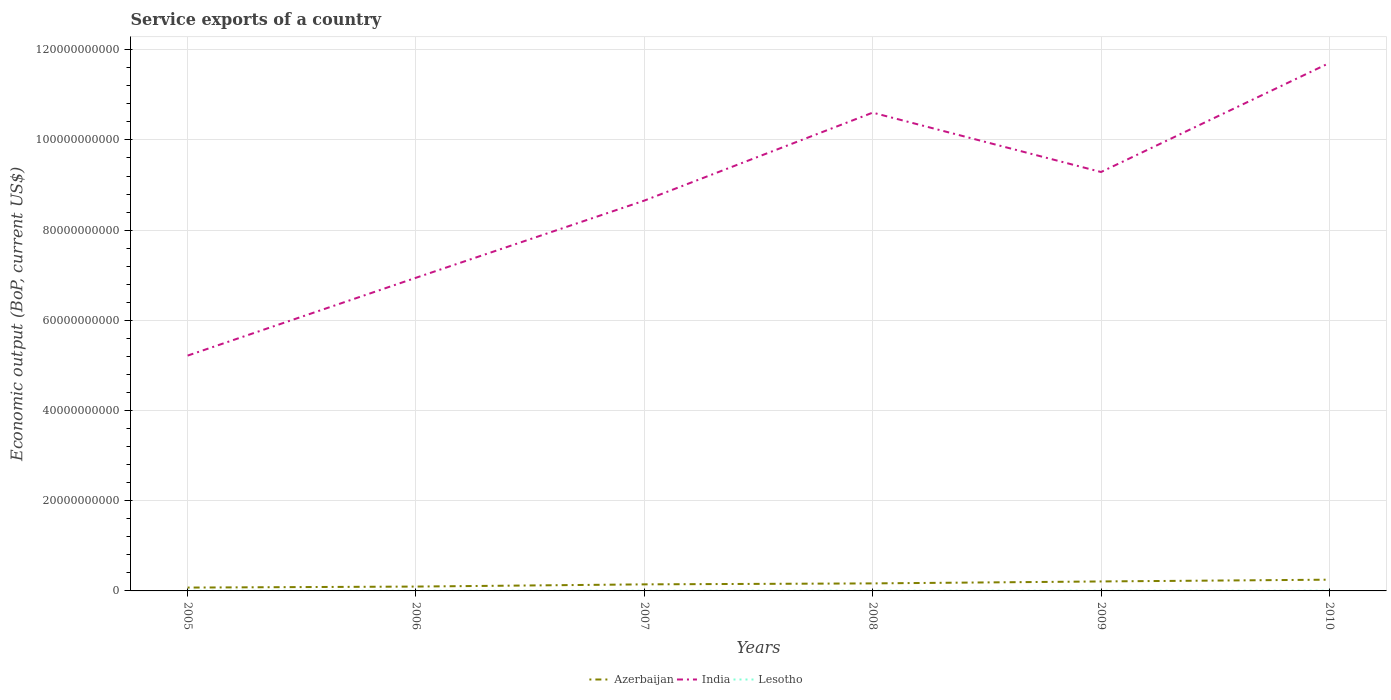Is the number of lines equal to the number of legend labels?
Offer a very short reply. Yes. Across all years, what is the maximum service exports in Lesotho?
Your answer should be very brief. 3.38e+07. In which year was the service exports in India maximum?
Make the answer very short. 2005. What is the total service exports in Azerbaijan in the graph?
Your response must be concise. -1.53e+09. What is the difference between the highest and the second highest service exports in Azerbaijan?
Offer a very short reply. 1.75e+09. Is the service exports in India strictly greater than the service exports in Azerbaijan over the years?
Offer a terse response. No. How many lines are there?
Your response must be concise. 3. Are the values on the major ticks of Y-axis written in scientific E-notation?
Keep it short and to the point. No. Does the graph contain any zero values?
Give a very brief answer. No. How many legend labels are there?
Offer a very short reply. 3. What is the title of the graph?
Offer a terse response. Service exports of a country. What is the label or title of the Y-axis?
Make the answer very short. Economic output (BoP, current US$). What is the Economic output (BoP, current US$) in Azerbaijan in 2005?
Provide a succinct answer. 7.41e+08. What is the Economic output (BoP, current US$) in India in 2005?
Give a very brief answer. 5.22e+1. What is the Economic output (BoP, current US$) in Lesotho in 2005?
Your response must be concise. 3.38e+07. What is the Economic output (BoP, current US$) in Azerbaijan in 2006?
Provide a succinct answer. 9.65e+08. What is the Economic output (BoP, current US$) in India in 2006?
Provide a succinct answer. 6.94e+1. What is the Economic output (BoP, current US$) in Lesotho in 2006?
Make the answer very short. 3.88e+07. What is the Economic output (BoP, current US$) in Azerbaijan in 2007?
Offer a terse response. 1.46e+09. What is the Economic output (BoP, current US$) in India in 2007?
Give a very brief answer. 8.66e+1. What is the Economic output (BoP, current US$) in Lesotho in 2007?
Give a very brief answer. 4.26e+07. What is the Economic output (BoP, current US$) in Azerbaijan in 2008?
Keep it short and to the point. 1.67e+09. What is the Economic output (BoP, current US$) of India in 2008?
Give a very brief answer. 1.06e+11. What is the Economic output (BoP, current US$) in Lesotho in 2008?
Make the answer very short. 4.83e+07. What is the Economic output (BoP, current US$) of Azerbaijan in 2009?
Provide a succinct answer. 2.10e+09. What is the Economic output (BoP, current US$) in India in 2009?
Your answer should be very brief. 9.29e+1. What is the Economic output (BoP, current US$) of Lesotho in 2009?
Give a very brief answer. 4.15e+07. What is the Economic output (BoP, current US$) of Azerbaijan in 2010?
Give a very brief answer. 2.49e+09. What is the Economic output (BoP, current US$) of India in 2010?
Make the answer very short. 1.17e+11. What is the Economic output (BoP, current US$) in Lesotho in 2010?
Offer a terse response. 4.77e+07. Across all years, what is the maximum Economic output (BoP, current US$) in Azerbaijan?
Offer a very short reply. 2.49e+09. Across all years, what is the maximum Economic output (BoP, current US$) of India?
Make the answer very short. 1.17e+11. Across all years, what is the maximum Economic output (BoP, current US$) of Lesotho?
Make the answer very short. 4.83e+07. Across all years, what is the minimum Economic output (BoP, current US$) in Azerbaijan?
Your answer should be compact. 7.41e+08. Across all years, what is the minimum Economic output (BoP, current US$) in India?
Your answer should be compact. 5.22e+1. Across all years, what is the minimum Economic output (BoP, current US$) in Lesotho?
Give a very brief answer. 3.38e+07. What is the total Economic output (BoP, current US$) of Azerbaijan in the graph?
Ensure brevity in your answer.  9.43e+09. What is the total Economic output (BoP, current US$) of India in the graph?
Ensure brevity in your answer.  5.24e+11. What is the total Economic output (BoP, current US$) of Lesotho in the graph?
Provide a succinct answer. 2.53e+08. What is the difference between the Economic output (BoP, current US$) in Azerbaijan in 2005 and that in 2006?
Ensure brevity in your answer.  -2.24e+08. What is the difference between the Economic output (BoP, current US$) in India in 2005 and that in 2006?
Provide a succinct answer. -1.73e+1. What is the difference between the Economic output (BoP, current US$) of Lesotho in 2005 and that in 2006?
Offer a very short reply. -5.01e+06. What is the difference between the Economic output (BoP, current US$) in Azerbaijan in 2005 and that in 2007?
Ensure brevity in your answer.  -7.14e+08. What is the difference between the Economic output (BoP, current US$) in India in 2005 and that in 2007?
Ensure brevity in your answer.  -3.44e+1. What is the difference between the Economic output (BoP, current US$) in Lesotho in 2005 and that in 2007?
Offer a very short reply. -8.77e+06. What is the difference between the Economic output (BoP, current US$) of Azerbaijan in 2005 and that in 2008?
Give a very brief answer. -9.27e+08. What is the difference between the Economic output (BoP, current US$) in India in 2005 and that in 2008?
Offer a very short reply. -5.39e+1. What is the difference between the Economic output (BoP, current US$) of Lesotho in 2005 and that in 2008?
Your answer should be compact. -1.46e+07. What is the difference between the Economic output (BoP, current US$) in Azerbaijan in 2005 and that in 2009?
Make the answer very short. -1.36e+09. What is the difference between the Economic output (BoP, current US$) in India in 2005 and that in 2009?
Give a very brief answer. -4.07e+1. What is the difference between the Economic output (BoP, current US$) of Lesotho in 2005 and that in 2009?
Your response must be concise. -7.75e+06. What is the difference between the Economic output (BoP, current US$) of Azerbaijan in 2005 and that in 2010?
Your response must be concise. -1.75e+09. What is the difference between the Economic output (BoP, current US$) of India in 2005 and that in 2010?
Ensure brevity in your answer.  -6.49e+1. What is the difference between the Economic output (BoP, current US$) of Lesotho in 2005 and that in 2010?
Provide a succinct answer. -1.39e+07. What is the difference between the Economic output (BoP, current US$) in Azerbaijan in 2006 and that in 2007?
Your answer should be very brief. -4.90e+08. What is the difference between the Economic output (BoP, current US$) of India in 2006 and that in 2007?
Give a very brief answer. -1.71e+1. What is the difference between the Economic output (BoP, current US$) in Lesotho in 2006 and that in 2007?
Ensure brevity in your answer.  -3.76e+06. What is the difference between the Economic output (BoP, current US$) of Azerbaijan in 2006 and that in 2008?
Give a very brief answer. -7.03e+08. What is the difference between the Economic output (BoP, current US$) of India in 2006 and that in 2008?
Your response must be concise. -3.66e+1. What is the difference between the Economic output (BoP, current US$) of Lesotho in 2006 and that in 2008?
Ensure brevity in your answer.  -9.54e+06. What is the difference between the Economic output (BoP, current US$) in Azerbaijan in 2006 and that in 2009?
Provide a succinct answer. -1.14e+09. What is the difference between the Economic output (BoP, current US$) of India in 2006 and that in 2009?
Give a very brief answer. -2.34e+1. What is the difference between the Economic output (BoP, current US$) in Lesotho in 2006 and that in 2009?
Keep it short and to the point. -2.74e+06. What is the difference between the Economic output (BoP, current US$) of Azerbaijan in 2006 and that in 2010?
Provide a succinct answer. -1.53e+09. What is the difference between the Economic output (BoP, current US$) in India in 2006 and that in 2010?
Make the answer very short. -4.76e+1. What is the difference between the Economic output (BoP, current US$) of Lesotho in 2006 and that in 2010?
Offer a terse response. -8.93e+06. What is the difference between the Economic output (BoP, current US$) of Azerbaijan in 2007 and that in 2008?
Your response must be concise. -2.13e+08. What is the difference between the Economic output (BoP, current US$) of India in 2007 and that in 2008?
Ensure brevity in your answer.  -1.95e+1. What is the difference between the Economic output (BoP, current US$) of Lesotho in 2007 and that in 2008?
Your answer should be very brief. -5.78e+06. What is the difference between the Economic output (BoP, current US$) in Azerbaijan in 2007 and that in 2009?
Make the answer very short. -6.45e+08. What is the difference between the Economic output (BoP, current US$) of India in 2007 and that in 2009?
Your answer should be very brief. -6.34e+09. What is the difference between the Economic output (BoP, current US$) of Lesotho in 2007 and that in 2009?
Ensure brevity in your answer.  1.02e+06. What is the difference between the Economic output (BoP, current US$) of Azerbaijan in 2007 and that in 2010?
Offer a very short reply. -1.04e+09. What is the difference between the Economic output (BoP, current US$) of India in 2007 and that in 2010?
Offer a terse response. -3.05e+1. What is the difference between the Economic output (BoP, current US$) of Lesotho in 2007 and that in 2010?
Provide a succinct answer. -5.17e+06. What is the difference between the Economic output (BoP, current US$) of Azerbaijan in 2008 and that in 2009?
Give a very brief answer. -4.32e+08. What is the difference between the Economic output (BoP, current US$) in India in 2008 and that in 2009?
Provide a succinct answer. 1.32e+1. What is the difference between the Economic output (BoP, current US$) of Lesotho in 2008 and that in 2009?
Your answer should be compact. 6.80e+06. What is the difference between the Economic output (BoP, current US$) of Azerbaijan in 2008 and that in 2010?
Keep it short and to the point. -8.25e+08. What is the difference between the Economic output (BoP, current US$) in India in 2008 and that in 2010?
Your answer should be very brief. -1.10e+1. What is the difference between the Economic output (BoP, current US$) in Lesotho in 2008 and that in 2010?
Provide a short and direct response. 6.12e+05. What is the difference between the Economic output (BoP, current US$) in Azerbaijan in 2009 and that in 2010?
Your response must be concise. -3.93e+08. What is the difference between the Economic output (BoP, current US$) of India in 2009 and that in 2010?
Your response must be concise. -2.42e+1. What is the difference between the Economic output (BoP, current US$) of Lesotho in 2009 and that in 2010?
Keep it short and to the point. -6.19e+06. What is the difference between the Economic output (BoP, current US$) of Azerbaijan in 2005 and the Economic output (BoP, current US$) of India in 2006?
Offer a terse response. -6.87e+1. What is the difference between the Economic output (BoP, current US$) in Azerbaijan in 2005 and the Economic output (BoP, current US$) in Lesotho in 2006?
Your response must be concise. 7.03e+08. What is the difference between the Economic output (BoP, current US$) of India in 2005 and the Economic output (BoP, current US$) of Lesotho in 2006?
Provide a short and direct response. 5.21e+1. What is the difference between the Economic output (BoP, current US$) in Azerbaijan in 2005 and the Economic output (BoP, current US$) in India in 2007?
Offer a very short reply. -8.58e+1. What is the difference between the Economic output (BoP, current US$) in Azerbaijan in 2005 and the Economic output (BoP, current US$) in Lesotho in 2007?
Make the answer very short. 6.99e+08. What is the difference between the Economic output (BoP, current US$) of India in 2005 and the Economic output (BoP, current US$) of Lesotho in 2007?
Make the answer very short. 5.21e+1. What is the difference between the Economic output (BoP, current US$) in Azerbaijan in 2005 and the Economic output (BoP, current US$) in India in 2008?
Your response must be concise. -1.05e+11. What is the difference between the Economic output (BoP, current US$) in Azerbaijan in 2005 and the Economic output (BoP, current US$) in Lesotho in 2008?
Provide a succinct answer. 6.93e+08. What is the difference between the Economic output (BoP, current US$) of India in 2005 and the Economic output (BoP, current US$) of Lesotho in 2008?
Ensure brevity in your answer.  5.21e+1. What is the difference between the Economic output (BoP, current US$) of Azerbaijan in 2005 and the Economic output (BoP, current US$) of India in 2009?
Make the answer very short. -9.21e+1. What is the difference between the Economic output (BoP, current US$) in Azerbaijan in 2005 and the Economic output (BoP, current US$) in Lesotho in 2009?
Provide a succinct answer. 7.00e+08. What is the difference between the Economic output (BoP, current US$) of India in 2005 and the Economic output (BoP, current US$) of Lesotho in 2009?
Provide a short and direct response. 5.21e+1. What is the difference between the Economic output (BoP, current US$) of Azerbaijan in 2005 and the Economic output (BoP, current US$) of India in 2010?
Your response must be concise. -1.16e+11. What is the difference between the Economic output (BoP, current US$) in Azerbaijan in 2005 and the Economic output (BoP, current US$) in Lesotho in 2010?
Your answer should be very brief. 6.94e+08. What is the difference between the Economic output (BoP, current US$) in India in 2005 and the Economic output (BoP, current US$) in Lesotho in 2010?
Make the answer very short. 5.21e+1. What is the difference between the Economic output (BoP, current US$) in Azerbaijan in 2006 and the Economic output (BoP, current US$) in India in 2007?
Keep it short and to the point. -8.56e+1. What is the difference between the Economic output (BoP, current US$) in Azerbaijan in 2006 and the Economic output (BoP, current US$) in Lesotho in 2007?
Ensure brevity in your answer.  9.23e+08. What is the difference between the Economic output (BoP, current US$) of India in 2006 and the Economic output (BoP, current US$) of Lesotho in 2007?
Ensure brevity in your answer.  6.94e+1. What is the difference between the Economic output (BoP, current US$) in Azerbaijan in 2006 and the Economic output (BoP, current US$) in India in 2008?
Your answer should be compact. -1.05e+11. What is the difference between the Economic output (BoP, current US$) of Azerbaijan in 2006 and the Economic output (BoP, current US$) of Lesotho in 2008?
Keep it short and to the point. 9.17e+08. What is the difference between the Economic output (BoP, current US$) in India in 2006 and the Economic output (BoP, current US$) in Lesotho in 2008?
Provide a short and direct response. 6.94e+1. What is the difference between the Economic output (BoP, current US$) in Azerbaijan in 2006 and the Economic output (BoP, current US$) in India in 2009?
Keep it short and to the point. -9.19e+1. What is the difference between the Economic output (BoP, current US$) of Azerbaijan in 2006 and the Economic output (BoP, current US$) of Lesotho in 2009?
Provide a succinct answer. 9.24e+08. What is the difference between the Economic output (BoP, current US$) of India in 2006 and the Economic output (BoP, current US$) of Lesotho in 2009?
Ensure brevity in your answer.  6.94e+1. What is the difference between the Economic output (BoP, current US$) of Azerbaijan in 2006 and the Economic output (BoP, current US$) of India in 2010?
Provide a succinct answer. -1.16e+11. What is the difference between the Economic output (BoP, current US$) in Azerbaijan in 2006 and the Economic output (BoP, current US$) in Lesotho in 2010?
Your answer should be very brief. 9.18e+08. What is the difference between the Economic output (BoP, current US$) in India in 2006 and the Economic output (BoP, current US$) in Lesotho in 2010?
Offer a very short reply. 6.94e+1. What is the difference between the Economic output (BoP, current US$) of Azerbaijan in 2007 and the Economic output (BoP, current US$) of India in 2008?
Your answer should be very brief. -1.05e+11. What is the difference between the Economic output (BoP, current US$) of Azerbaijan in 2007 and the Economic output (BoP, current US$) of Lesotho in 2008?
Offer a terse response. 1.41e+09. What is the difference between the Economic output (BoP, current US$) in India in 2007 and the Economic output (BoP, current US$) in Lesotho in 2008?
Keep it short and to the point. 8.65e+1. What is the difference between the Economic output (BoP, current US$) in Azerbaijan in 2007 and the Economic output (BoP, current US$) in India in 2009?
Provide a short and direct response. -9.14e+1. What is the difference between the Economic output (BoP, current US$) in Azerbaijan in 2007 and the Economic output (BoP, current US$) in Lesotho in 2009?
Provide a succinct answer. 1.41e+09. What is the difference between the Economic output (BoP, current US$) of India in 2007 and the Economic output (BoP, current US$) of Lesotho in 2009?
Provide a succinct answer. 8.65e+1. What is the difference between the Economic output (BoP, current US$) in Azerbaijan in 2007 and the Economic output (BoP, current US$) in India in 2010?
Make the answer very short. -1.16e+11. What is the difference between the Economic output (BoP, current US$) of Azerbaijan in 2007 and the Economic output (BoP, current US$) of Lesotho in 2010?
Provide a short and direct response. 1.41e+09. What is the difference between the Economic output (BoP, current US$) in India in 2007 and the Economic output (BoP, current US$) in Lesotho in 2010?
Provide a short and direct response. 8.65e+1. What is the difference between the Economic output (BoP, current US$) in Azerbaijan in 2008 and the Economic output (BoP, current US$) in India in 2009?
Offer a terse response. -9.12e+1. What is the difference between the Economic output (BoP, current US$) in Azerbaijan in 2008 and the Economic output (BoP, current US$) in Lesotho in 2009?
Your answer should be compact. 1.63e+09. What is the difference between the Economic output (BoP, current US$) in India in 2008 and the Economic output (BoP, current US$) in Lesotho in 2009?
Ensure brevity in your answer.  1.06e+11. What is the difference between the Economic output (BoP, current US$) in Azerbaijan in 2008 and the Economic output (BoP, current US$) in India in 2010?
Ensure brevity in your answer.  -1.15e+11. What is the difference between the Economic output (BoP, current US$) in Azerbaijan in 2008 and the Economic output (BoP, current US$) in Lesotho in 2010?
Ensure brevity in your answer.  1.62e+09. What is the difference between the Economic output (BoP, current US$) in India in 2008 and the Economic output (BoP, current US$) in Lesotho in 2010?
Your response must be concise. 1.06e+11. What is the difference between the Economic output (BoP, current US$) of Azerbaijan in 2009 and the Economic output (BoP, current US$) of India in 2010?
Provide a short and direct response. -1.15e+11. What is the difference between the Economic output (BoP, current US$) in Azerbaijan in 2009 and the Economic output (BoP, current US$) in Lesotho in 2010?
Ensure brevity in your answer.  2.05e+09. What is the difference between the Economic output (BoP, current US$) in India in 2009 and the Economic output (BoP, current US$) in Lesotho in 2010?
Provide a short and direct response. 9.28e+1. What is the average Economic output (BoP, current US$) in Azerbaijan per year?
Keep it short and to the point. 1.57e+09. What is the average Economic output (BoP, current US$) in India per year?
Your answer should be very brief. 8.74e+1. What is the average Economic output (BoP, current US$) of Lesotho per year?
Provide a succinct answer. 4.21e+07. In the year 2005, what is the difference between the Economic output (BoP, current US$) in Azerbaijan and Economic output (BoP, current US$) in India?
Provide a succinct answer. -5.14e+1. In the year 2005, what is the difference between the Economic output (BoP, current US$) in Azerbaijan and Economic output (BoP, current US$) in Lesotho?
Keep it short and to the point. 7.08e+08. In the year 2005, what is the difference between the Economic output (BoP, current US$) in India and Economic output (BoP, current US$) in Lesotho?
Make the answer very short. 5.21e+1. In the year 2006, what is the difference between the Economic output (BoP, current US$) in Azerbaijan and Economic output (BoP, current US$) in India?
Ensure brevity in your answer.  -6.85e+1. In the year 2006, what is the difference between the Economic output (BoP, current US$) in Azerbaijan and Economic output (BoP, current US$) in Lesotho?
Ensure brevity in your answer.  9.27e+08. In the year 2006, what is the difference between the Economic output (BoP, current US$) of India and Economic output (BoP, current US$) of Lesotho?
Your answer should be compact. 6.94e+1. In the year 2007, what is the difference between the Economic output (BoP, current US$) of Azerbaijan and Economic output (BoP, current US$) of India?
Give a very brief answer. -8.51e+1. In the year 2007, what is the difference between the Economic output (BoP, current US$) of Azerbaijan and Economic output (BoP, current US$) of Lesotho?
Give a very brief answer. 1.41e+09. In the year 2007, what is the difference between the Economic output (BoP, current US$) in India and Economic output (BoP, current US$) in Lesotho?
Your answer should be compact. 8.65e+1. In the year 2008, what is the difference between the Economic output (BoP, current US$) of Azerbaijan and Economic output (BoP, current US$) of India?
Offer a very short reply. -1.04e+11. In the year 2008, what is the difference between the Economic output (BoP, current US$) in Azerbaijan and Economic output (BoP, current US$) in Lesotho?
Your answer should be very brief. 1.62e+09. In the year 2008, what is the difference between the Economic output (BoP, current US$) of India and Economic output (BoP, current US$) of Lesotho?
Keep it short and to the point. 1.06e+11. In the year 2009, what is the difference between the Economic output (BoP, current US$) of Azerbaijan and Economic output (BoP, current US$) of India?
Provide a short and direct response. -9.08e+1. In the year 2009, what is the difference between the Economic output (BoP, current US$) of Azerbaijan and Economic output (BoP, current US$) of Lesotho?
Offer a very short reply. 2.06e+09. In the year 2009, what is the difference between the Economic output (BoP, current US$) in India and Economic output (BoP, current US$) in Lesotho?
Your response must be concise. 9.28e+1. In the year 2010, what is the difference between the Economic output (BoP, current US$) of Azerbaijan and Economic output (BoP, current US$) of India?
Keep it short and to the point. -1.15e+11. In the year 2010, what is the difference between the Economic output (BoP, current US$) of Azerbaijan and Economic output (BoP, current US$) of Lesotho?
Your response must be concise. 2.45e+09. In the year 2010, what is the difference between the Economic output (BoP, current US$) in India and Economic output (BoP, current US$) in Lesotho?
Your response must be concise. 1.17e+11. What is the ratio of the Economic output (BoP, current US$) in Azerbaijan in 2005 to that in 2006?
Provide a succinct answer. 0.77. What is the ratio of the Economic output (BoP, current US$) of India in 2005 to that in 2006?
Provide a succinct answer. 0.75. What is the ratio of the Economic output (BoP, current US$) in Lesotho in 2005 to that in 2006?
Ensure brevity in your answer.  0.87. What is the ratio of the Economic output (BoP, current US$) of Azerbaijan in 2005 to that in 2007?
Give a very brief answer. 0.51. What is the ratio of the Economic output (BoP, current US$) in India in 2005 to that in 2007?
Your answer should be very brief. 0.6. What is the ratio of the Economic output (BoP, current US$) in Lesotho in 2005 to that in 2007?
Provide a short and direct response. 0.79. What is the ratio of the Economic output (BoP, current US$) of Azerbaijan in 2005 to that in 2008?
Give a very brief answer. 0.44. What is the ratio of the Economic output (BoP, current US$) in India in 2005 to that in 2008?
Offer a very short reply. 0.49. What is the ratio of the Economic output (BoP, current US$) of Lesotho in 2005 to that in 2008?
Give a very brief answer. 0.7. What is the ratio of the Economic output (BoP, current US$) in Azerbaijan in 2005 to that in 2009?
Offer a very short reply. 0.35. What is the ratio of the Economic output (BoP, current US$) of India in 2005 to that in 2009?
Offer a very short reply. 0.56. What is the ratio of the Economic output (BoP, current US$) in Lesotho in 2005 to that in 2009?
Offer a very short reply. 0.81. What is the ratio of the Economic output (BoP, current US$) in Azerbaijan in 2005 to that in 2010?
Provide a short and direct response. 0.3. What is the ratio of the Economic output (BoP, current US$) in India in 2005 to that in 2010?
Keep it short and to the point. 0.45. What is the ratio of the Economic output (BoP, current US$) of Lesotho in 2005 to that in 2010?
Provide a succinct answer. 0.71. What is the ratio of the Economic output (BoP, current US$) in Azerbaijan in 2006 to that in 2007?
Provide a succinct answer. 0.66. What is the ratio of the Economic output (BoP, current US$) of India in 2006 to that in 2007?
Make the answer very short. 0.8. What is the ratio of the Economic output (BoP, current US$) of Lesotho in 2006 to that in 2007?
Give a very brief answer. 0.91. What is the ratio of the Economic output (BoP, current US$) of Azerbaijan in 2006 to that in 2008?
Your response must be concise. 0.58. What is the ratio of the Economic output (BoP, current US$) of India in 2006 to that in 2008?
Provide a short and direct response. 0.65. What is the ratio of the Economic output (BoP, current US$) in Lesotho in 2006 to that in 2008?
Provide a short and direct response. 0.8. What is the ratio of the Economic output (BoP, current US$) of Azerbaijan in 2006 to that in 2009?
Your response must be concise. 0.46. What is the ratio of the Economic output (BoP, current US$) of India in 2006 to that in 2009?
Provide a short and direct response. 0.75. What is the ratio of the Economic output (BoP, current US$) in Lesotho in 2006 to that in 2009?
Give a very brief answer. 0.93. What is the ratio of the Economic output (BoP, current US$) in Azerbaijan in 2006 to that in 2010?
Make the answer very short. 0.39. What is the ratio of the Economic output (BoP, current US$) in India in 2006 to that in 2010?
Keep it short and to the point. 0.59. What is the ratio of the Economic output (BoP, current US$) of Lesotho in 2006 to that in 2010?
Ensure brevity in your answer.  0.81. What is the ratio of the Economic output (BoP, current US$) of Azerbaijan in 2007 to that in 2008?
Make the answer very short. 0.87. What is the ratio of the Economic output (BoP, current US$) of India in 2007 to that in 2008?
Provide a short and direct response. 0.82. What is the ratio of the Economic output (BoP, current US$) in Lesotho in 2007 to that in 2008?
Your answer should be compact. 0.88. What is the ratio of the Economic output (BoP, current US$) in Azerbaijan in 2007 to that in 2009?
Keep it short and to the point. 0.69. What is the ratio of the Economic output (BoP, current US$) of India in 2007 to that in 2009?
Your response must be concise. 0.93. What is the ratio of the Economic output (BoP, current US$) of Lesotho in 2007 to that in 2009?
Offer a very short reply. 1.02. What is the ratio of the Economic output (BoP, current US$) of Azerbaijan in 2007 to that in 2010?
Keep it short and to the point. 0.58. What is the ratio of the Economic output (BoP, current US$) of India in 2007 to that in 2010?
Make the answer very short. 0.74. What is the ratio of the Economic output (BoP, current US$) in Lesotho in 2007 to that in 2010?
Ensure brevity in your answer.  0.89. What is the ratio of the Economic output (BoP, current US$) in Azerbaijan in 2008 to that in 2009?
Your response must be concise. 0.79. What is the ratio of the Economic output (BoP, current US$) of India in 2008 to that in 2009?
Your answer should be compact. 1.14. What is the ratio of the Economic output (BoP, current US$) of Lesotho in 2008 to that in 2009?
Your answer should be compact. 1.16. What is the ratio of the Economic output (BoP, current US$) in Azerbaijan in 2008 to that in 2010?
Your answer should be very brief. 0.67. What is the ratio of the Economic output (BoP, current US$) in India in 2008 to that in 2010?
Your answer should be compact. 0.91. What is the ratio of the Economic output (BoP, current US$) in Lesotho in 2008 to that in 2010?
Keep it short and to the point. 1.01. What is the ratio of the Economic output (BoP, current US$) in Azerbaijan in 2009 to that in 2010?
Make the answer very short. 0.84. What is the ratio of the Economic output (BoP, current US$) in India in 2009 to that in 2010?
Your response must be concise. 0.79. What is the ratio of the Economic output (BoP, current US$) of Lesotho in 2009 to that in 2010?
Provide a short and direct response. 0.87. What is the difference between the highest and the second highest Economic output (BoP, current US$) in Azerbaijan?
Provide a short and direct response. 3.93e+08. What is the difference between the highest and the second highest Economic output (BoP, current US$) of India?
Provide a succinct answer. 1.10e+1. What is the difference between the highest and the second highest Economic output (BoP, current US$) in Lesotho?
Keep it short and to the point. 6.12e+05. What is the difference between the highest and the lowest Economic output (BoP, current US$) of Azerbaijan?
Offer a very short reply. 1.75e+09. What is the difference between the highest and the lowest Economic output (BoP, current US$) of India?
Your answer should be compact. 6.49e+1. What is the difference between the highest and the lowest Economic output (BoP, current US$) of Lesotho?
Your answer should be very brief. 1.46e+07. 